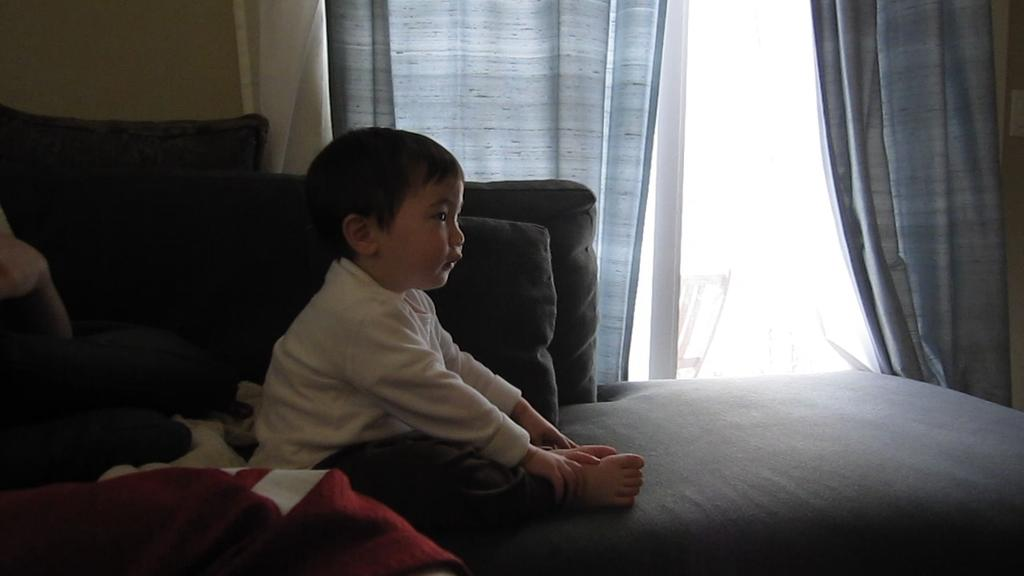What is the main subject in the image? There is a kid on the bed in the image. What can be seen in the background of the image? There is a window with curtains in the image. What objects are in the middle of the image? There are pillows in the middle of the image. Where is the cloth located in the image? There is a cloth in the bottom left of the image. How many icicles are hanging from the window in the image? There are no icicles present in the image; it features a window with curtains. What type of planes can be seen transporting goods in the image? There are no planes or transportation of goods depicted in the image. 